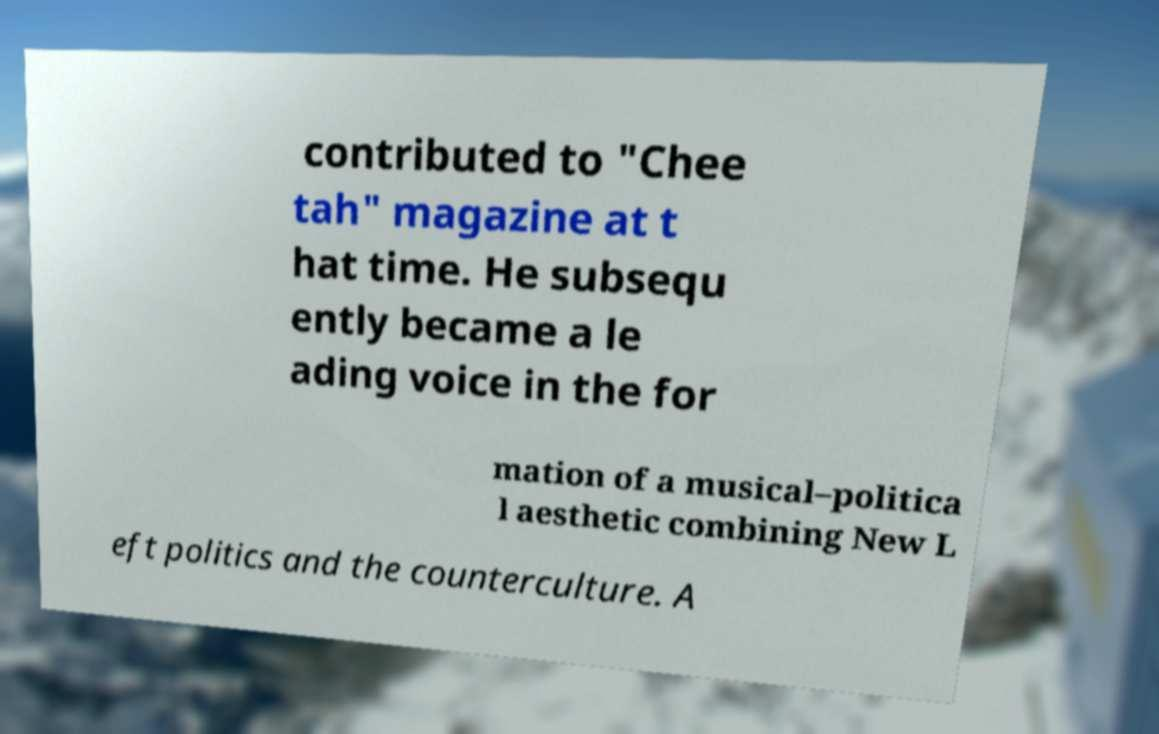For documentation purposes, I need the text within this image transcribed. Could you provide that? contributed to "Chee tah" magazine at t hat time. He subsequ ently became a le ading voice in the for mation of a musical–politica l aesthetic combining New L eft politics and the counterculture. A 